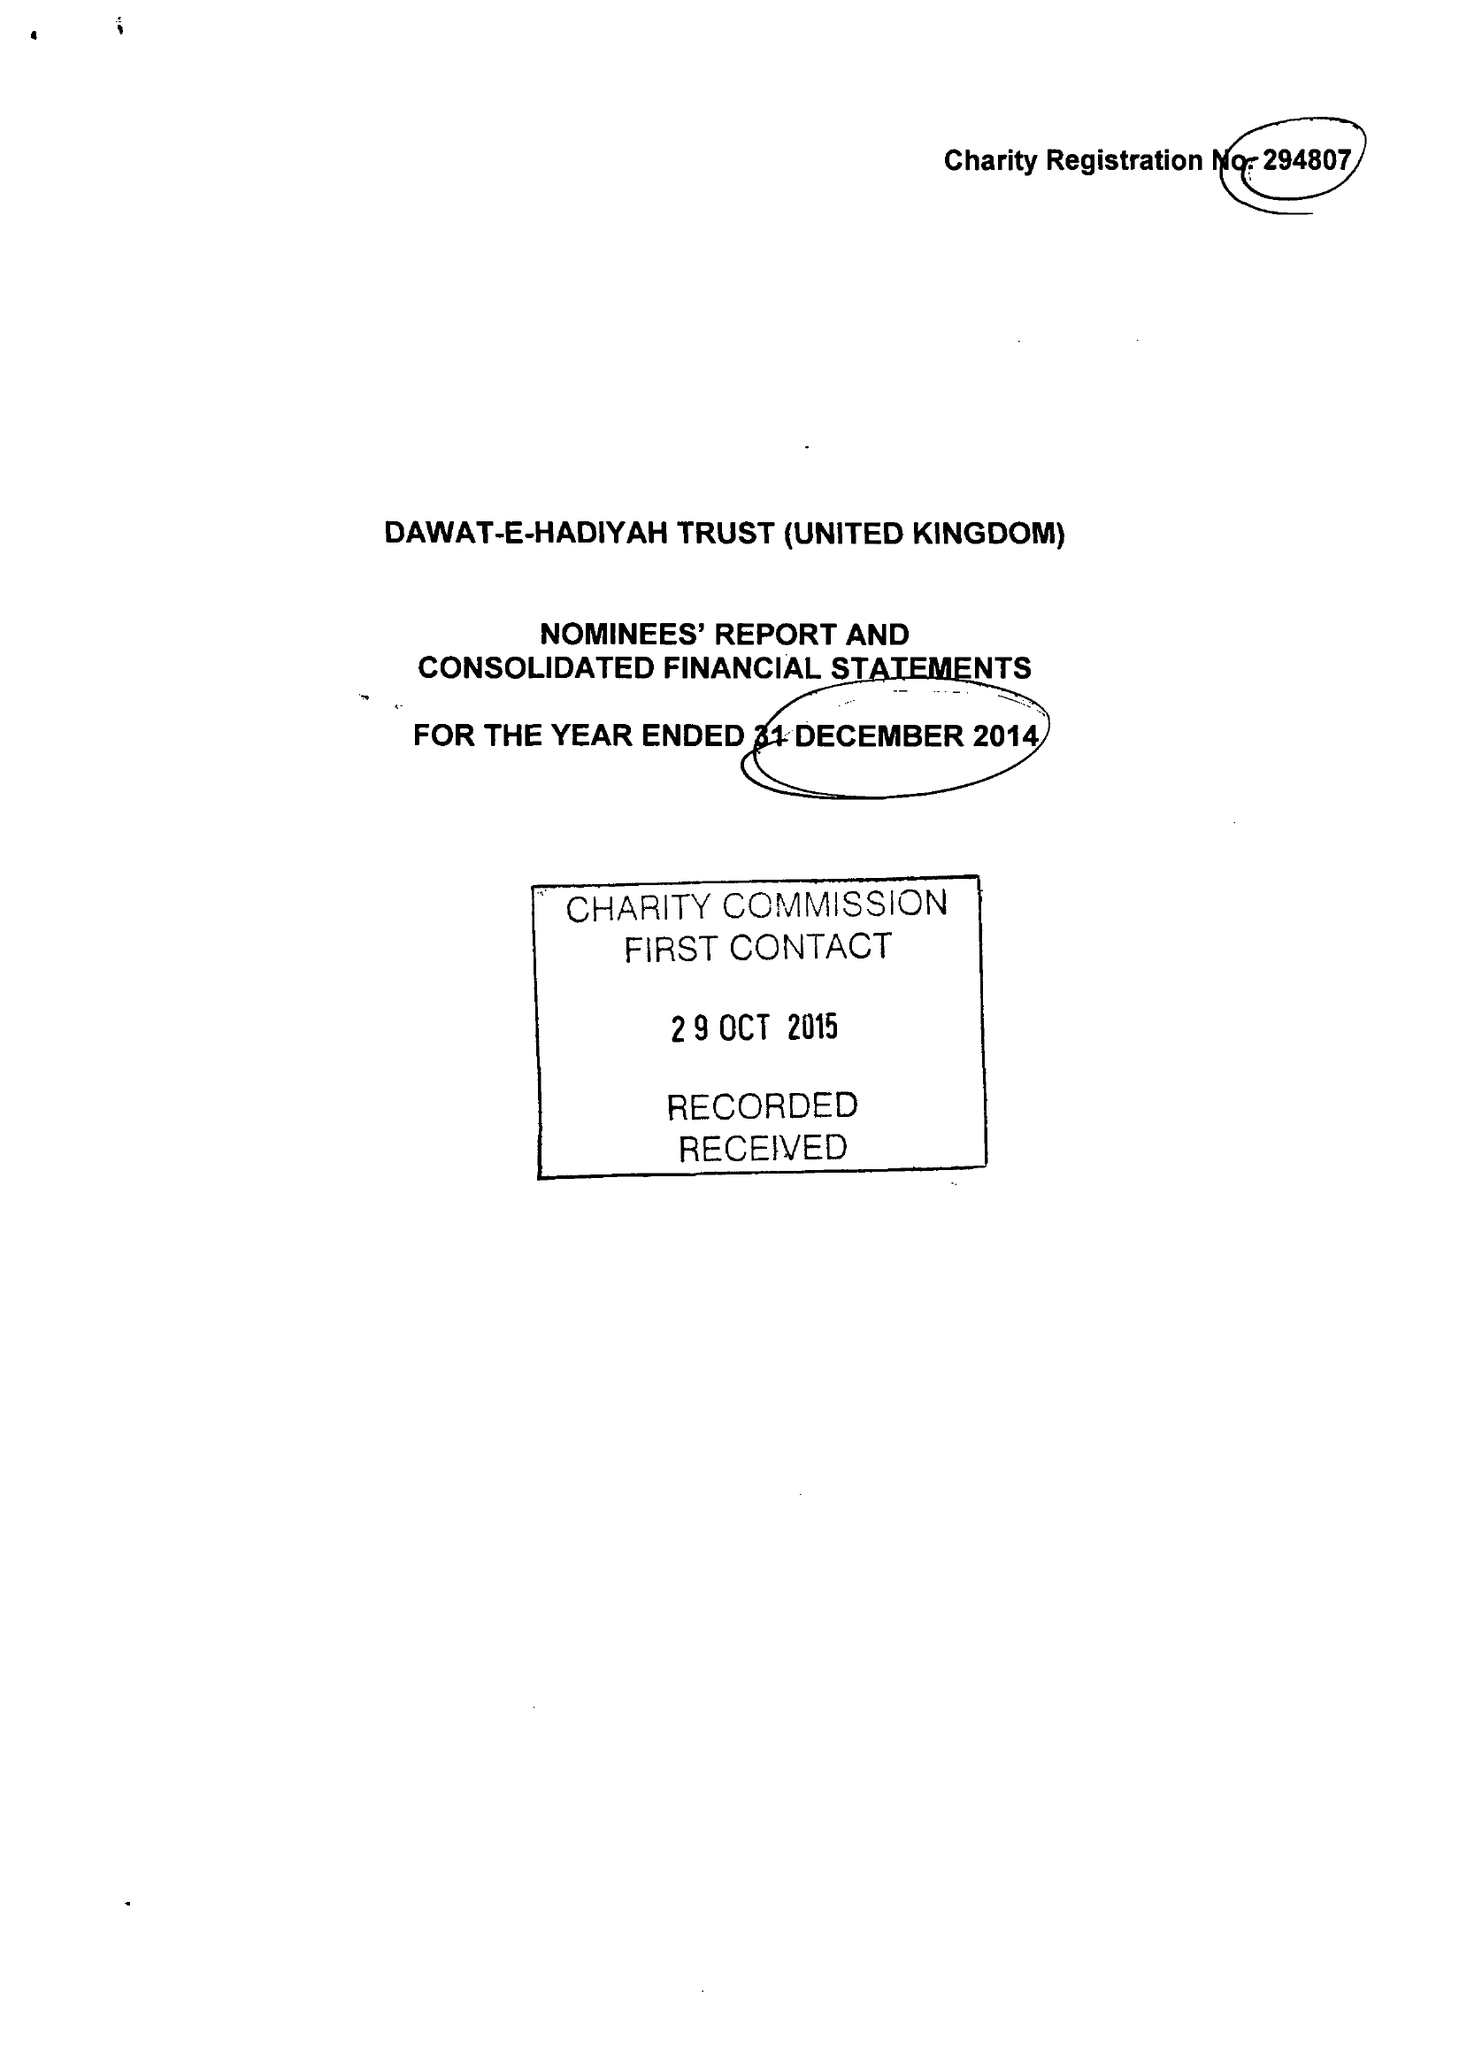What is the value for the address__postcode?
Answer the question using a single word or phrase. UB5 6AG 